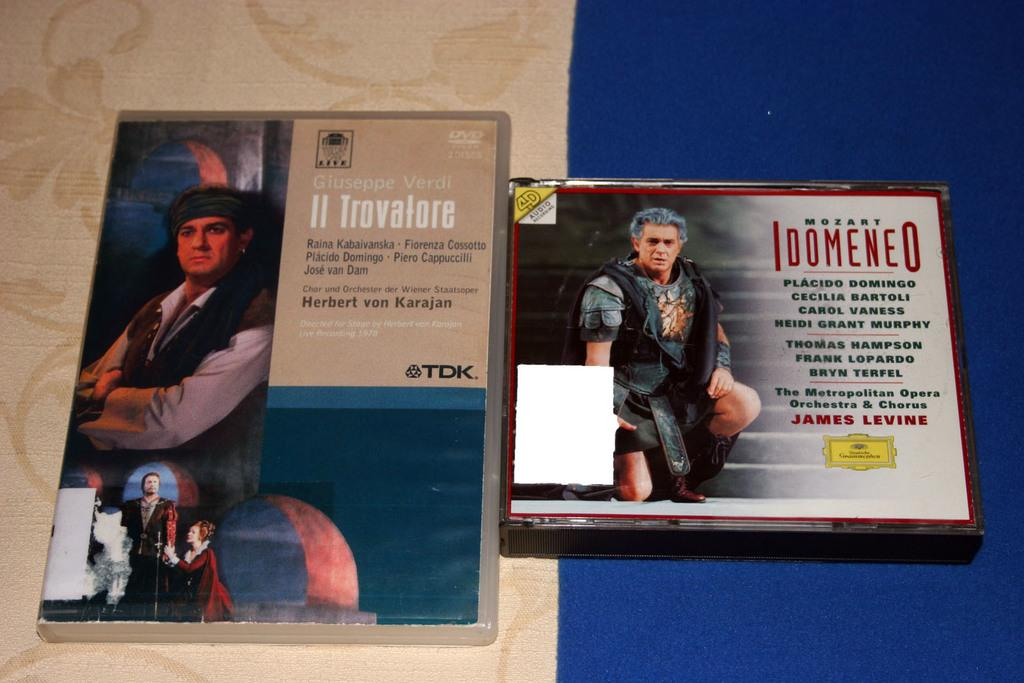Provide a one-sentence caption for the provided image. A DVD and a CD, featuring music by Mozart, are sitting side by side. 